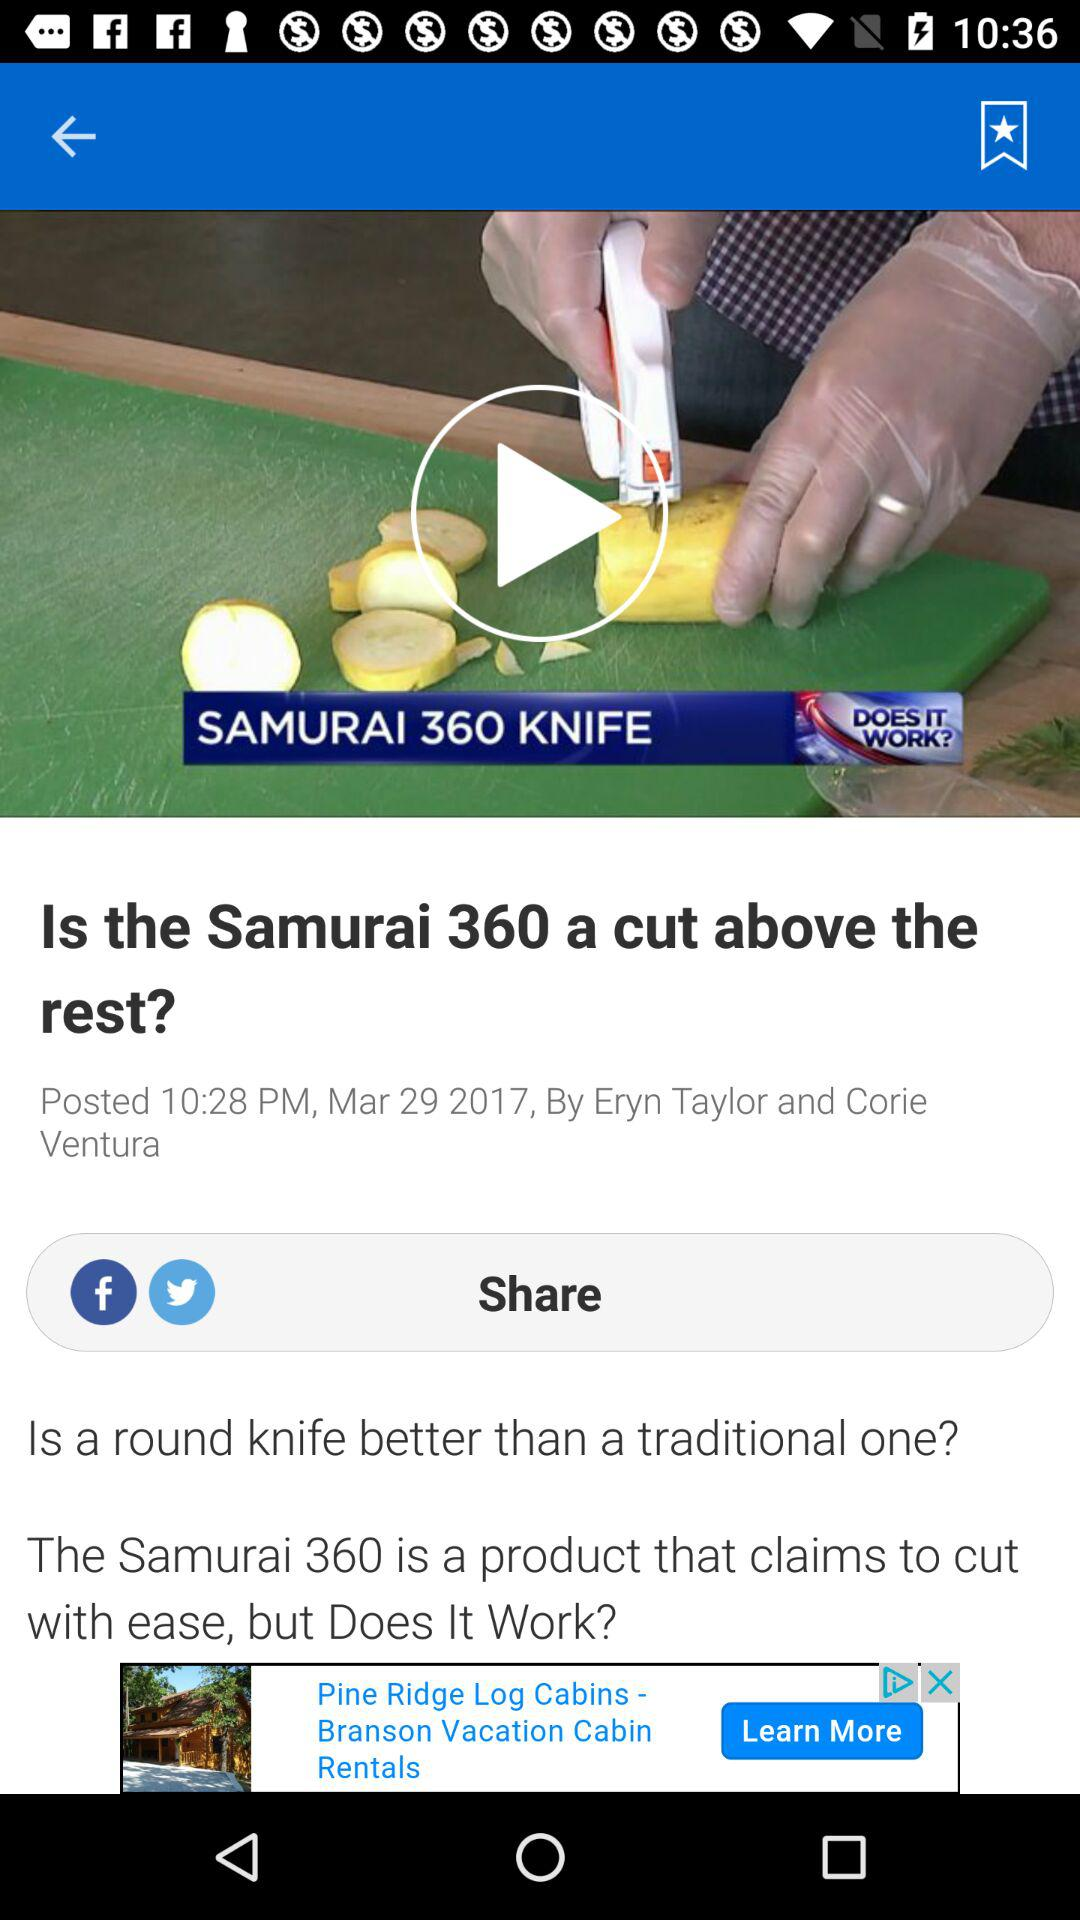Who is the author of the article? The authors of the article are Eryn Taylor and Corie Ventura. 